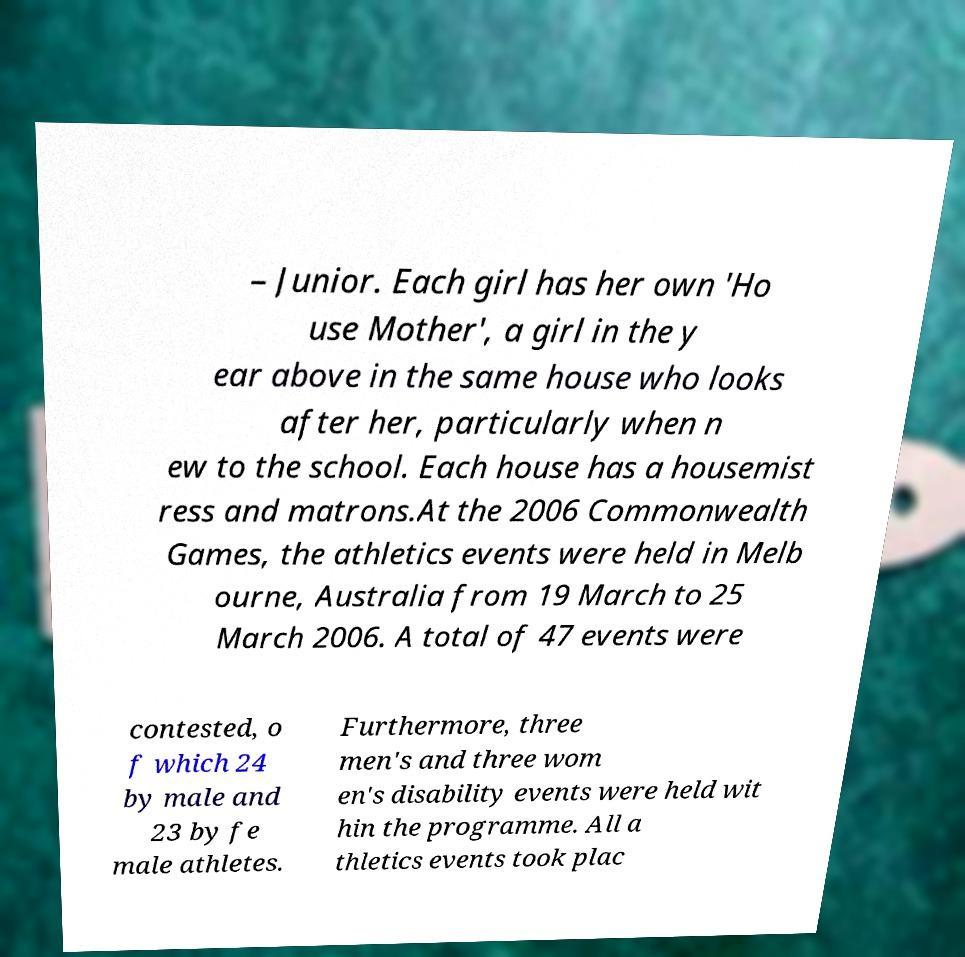I need the written content from this picture converted into text. Can you do that? – Junior. Each girl has her own 'Ho use Mother', a girl in the y ear above in the same house who looks after her, particularly when n ew to the school. Each house has a housemist ress and matrons.At the 2006 Commonwealth Games, the athletics events were held in Melb ourne, Australia from 19 March to 25 March 2006. A total of 47 events were contested, o f which 24 by male and 23 by fe male athletes. Furthermore, three men's and three wom en's disability events were held wit hin the programme. All a thletics events took plac 